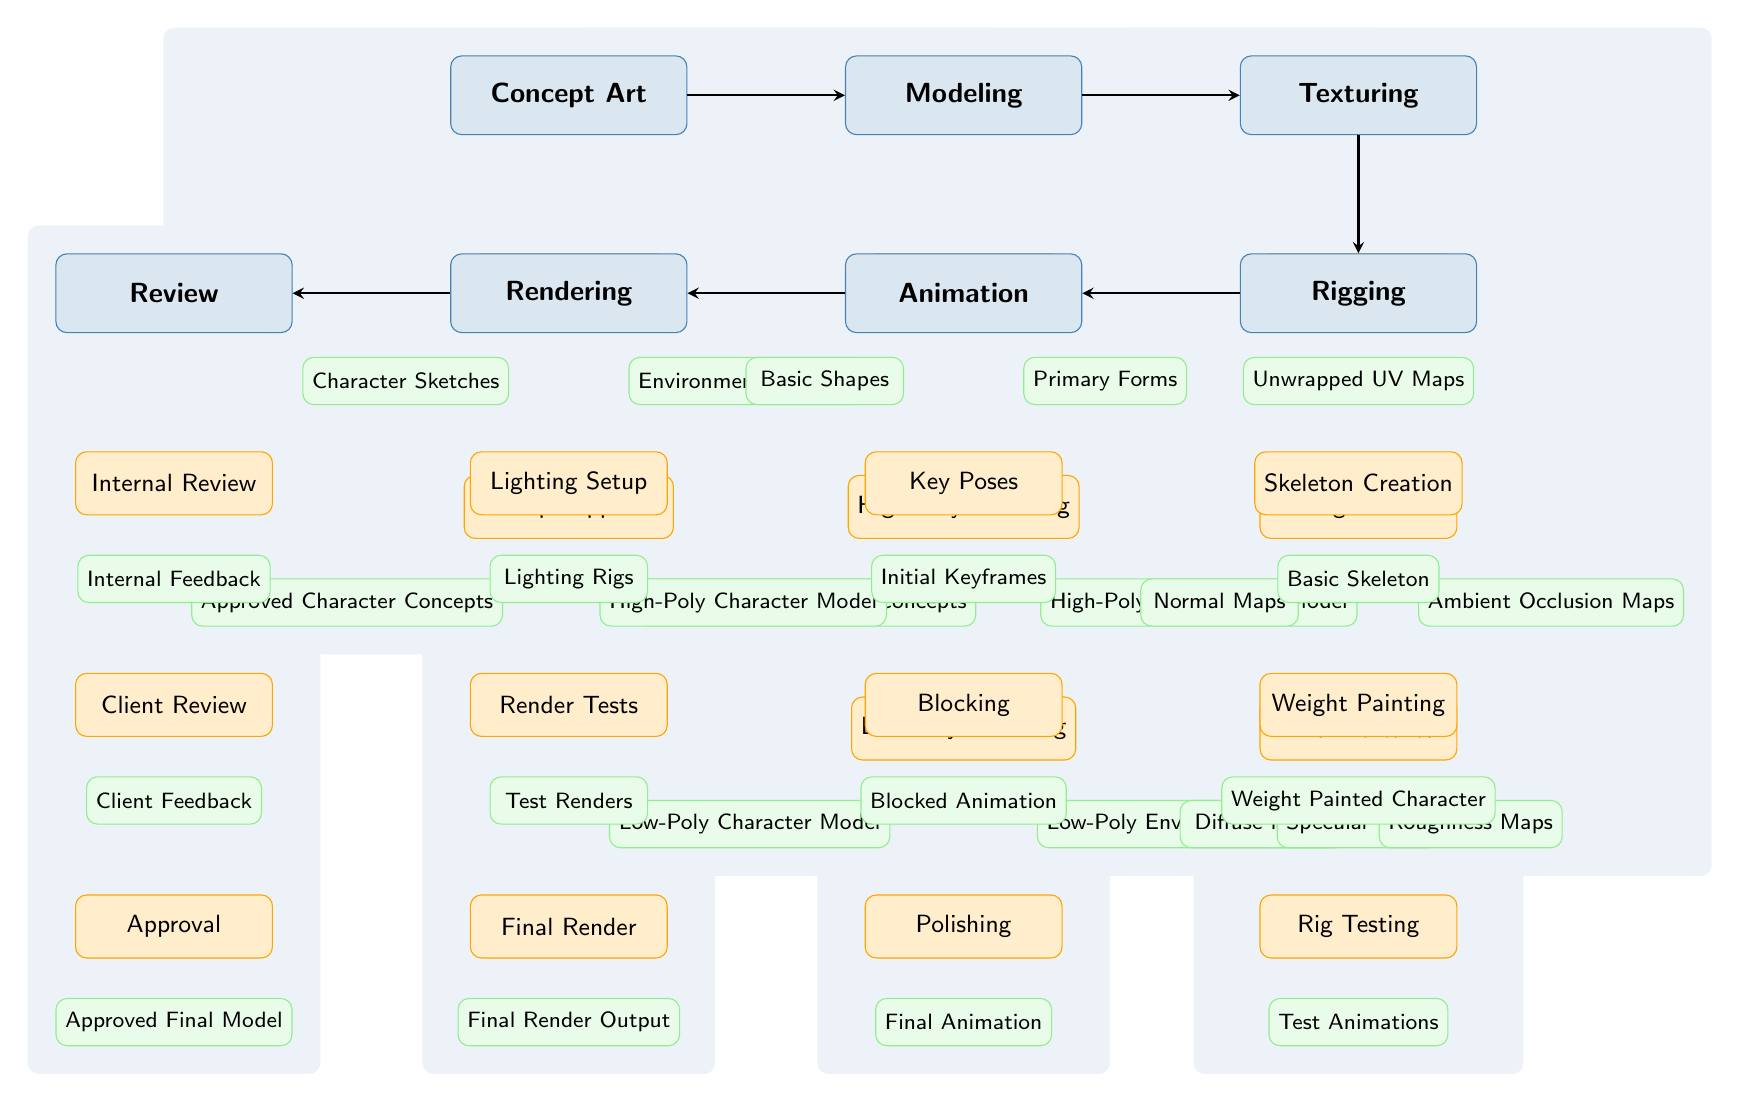What is the first phase in the 3D modeling pipeline? The first phase listed in the diagram is "Concept Art," which is shown at the top left of the diagram.
Answer: Concept Art How many deliverables are associated with the "Modeling" phase? In the "Modeling" phase, there are a total of four deliverables: "High-Poly Character Model," "High-Poly Environment Model," "Low-Poly Character Model," and "Low-Poly Environment Model."
Answer: Four What milestone follows "Baking Textures"? "Final Textures" is the milestone that comes after "Baking Textures" as indicated by their vertical arrangement in the texturing phase.
Answer: Final Textures Which phase comes before "Rigging"? The phase that comes immediately before "Rigging" is "Texturing," as shown in the flow of the diagram from the texturing to the rigging phase.
Answer: Texturing What are the deliverables that come after the "Final Textures" milestone? The deliverables that follow "Final Textures" are "Diffuse Maps," "Specular Maps," and "Roughness Maps," which are all positioned below it in the texturing phase of the diagram.
Answer: Diffuse Maps, Specular Maps, Roughness Maps What is the last milestone in the 3D modeling pipeline? The last milestone in the pipeline is "Approval," which appears at the bottom of the review phase, marking the final step in the process prior to achieving the approved model.
Answer: Approval What deliverable is associated with "Rig Testing"? The deliverable that corresponds to "Rig Testing" is "Test Animations," which is listed directly beneath the "Rig Testing" milestone in the rigging phase.
Answer: Test Animations How many phases are represented in the diagram? There are a total of six phases represented in the diagram: "Concept Art," "Modeling," "Texturing," "Rigging," "Animation," and "Rendering."
Answer: Six What is the relationship between "Key Poses" and "Blocked Animation"? "Key Poses" is a milestone that precedes "Blocked Animation," as seen in the progression of the animation phase where one leads into the other.
Answer: Key Poses precedes Blocked Animation 